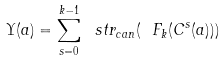Convert formula to latex. <formula><loc_0><loc_0><loc_500><loc_500>\Upsilon ( a ) = \sum _ { s = 0 } ^ { k - 1 } \ s t r _ { c a n } ( \ F _ { k } ( C ^ { s } ( a ) ) )</formula> 